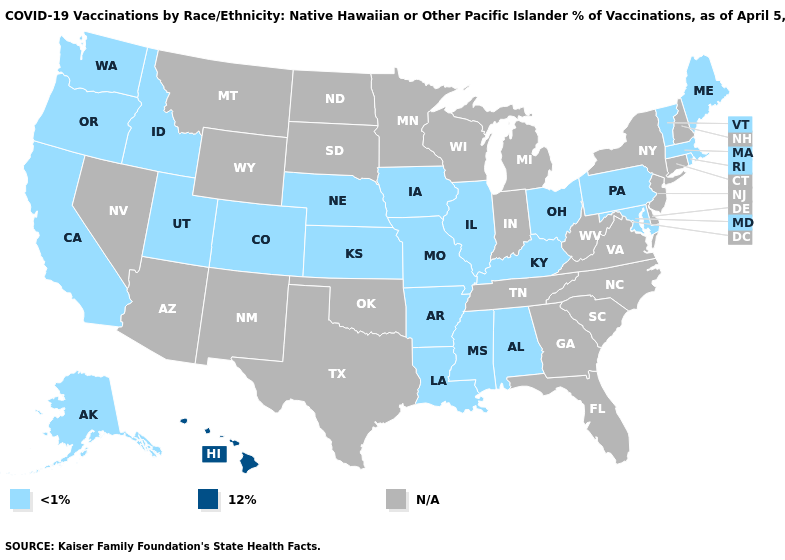What is the lowest value in the USA?
Be succinct. <1%. Which states have the lowest value in the West?
Be succinct. Alaska, California, Colorado, Idaho, Oregon, Utah, Washington. What is the lowest value in the Northeast?
Short answer required. <1%. What is the highest value in states that border New Mexico?
Concise answer only. <1%. Name the states that have a value in the range 12%?
Short answer required. Hawaii. What is the highest value in the USA?
Keep it brief. 12%. Does Iowa have the highest value in the USA?
Keep it brief. No. What is the lowest value in the MidWest?
Write a very short answer. <1%. Which states have the lowest value in the Northeast?
Keep it brief. Maine, Massachusetts, Pennsylvania, Rhode Island, Vermont. Is the legend a continuous bar?
Concise answer only. No. Name the states that have a value in the range N/A?
Quick response, please. Arizona, Connecticut, Delaware, Florida, Georgia, Indiana, Michigan, Minnesota, Montana, Nevada, New Hampshire, New Jersey, New Mexico, New York, North Carolina, North Dakota, Oklahoma, South Carolina, South Dakota, Tennessee, Texas, Virginia, West Virginia, Wisconsin, Wyoming. What is the highest value in states that border Georgia?
Answer briefly. <1%. 